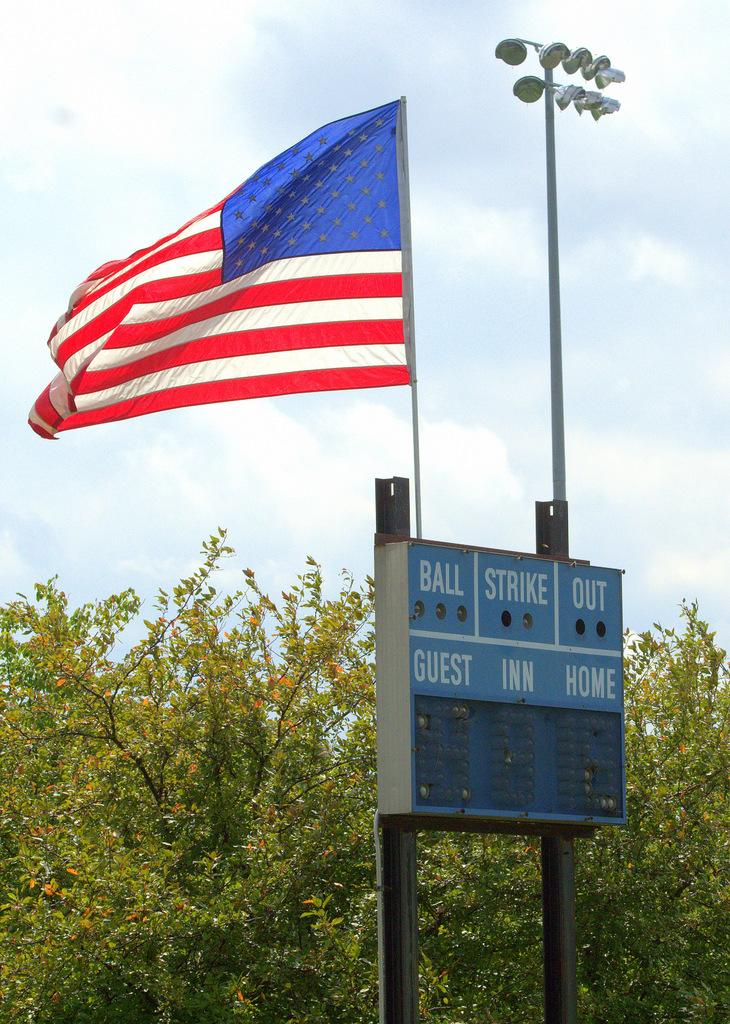What is the main object in the middle of the image? There is a board in the middle of the image. What other object can be seen in the image? There is a flag in the image. What type of natural environment is visible in the image? There are trees visible in the image. How would you describe the weather in the image? The sky is cloudy in the image. What type of feeling can be seen on the board in the image? There is no feeling present on the board in the image; it is an inanimate object. 